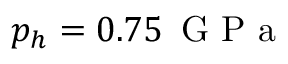Convert formula to latex. <formula><loc_0><loc_0><loc_500><loc_500>p _ { h } = 0 . 7 5 \, G P a</formula> 